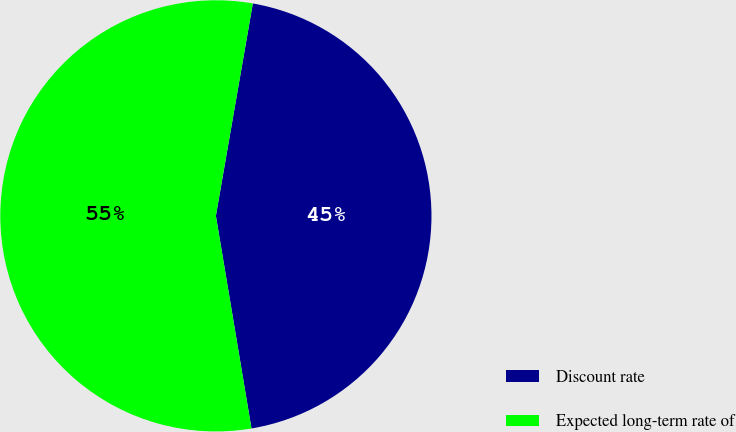Convert chart. <chart><loc_0><loc_0><loc_500><loc_500><pie_chart><fcel>Discount rate<fcel>Expected long-term rate of<nl><fcel>44.62%<fcel>55.38%<nl></chart> 